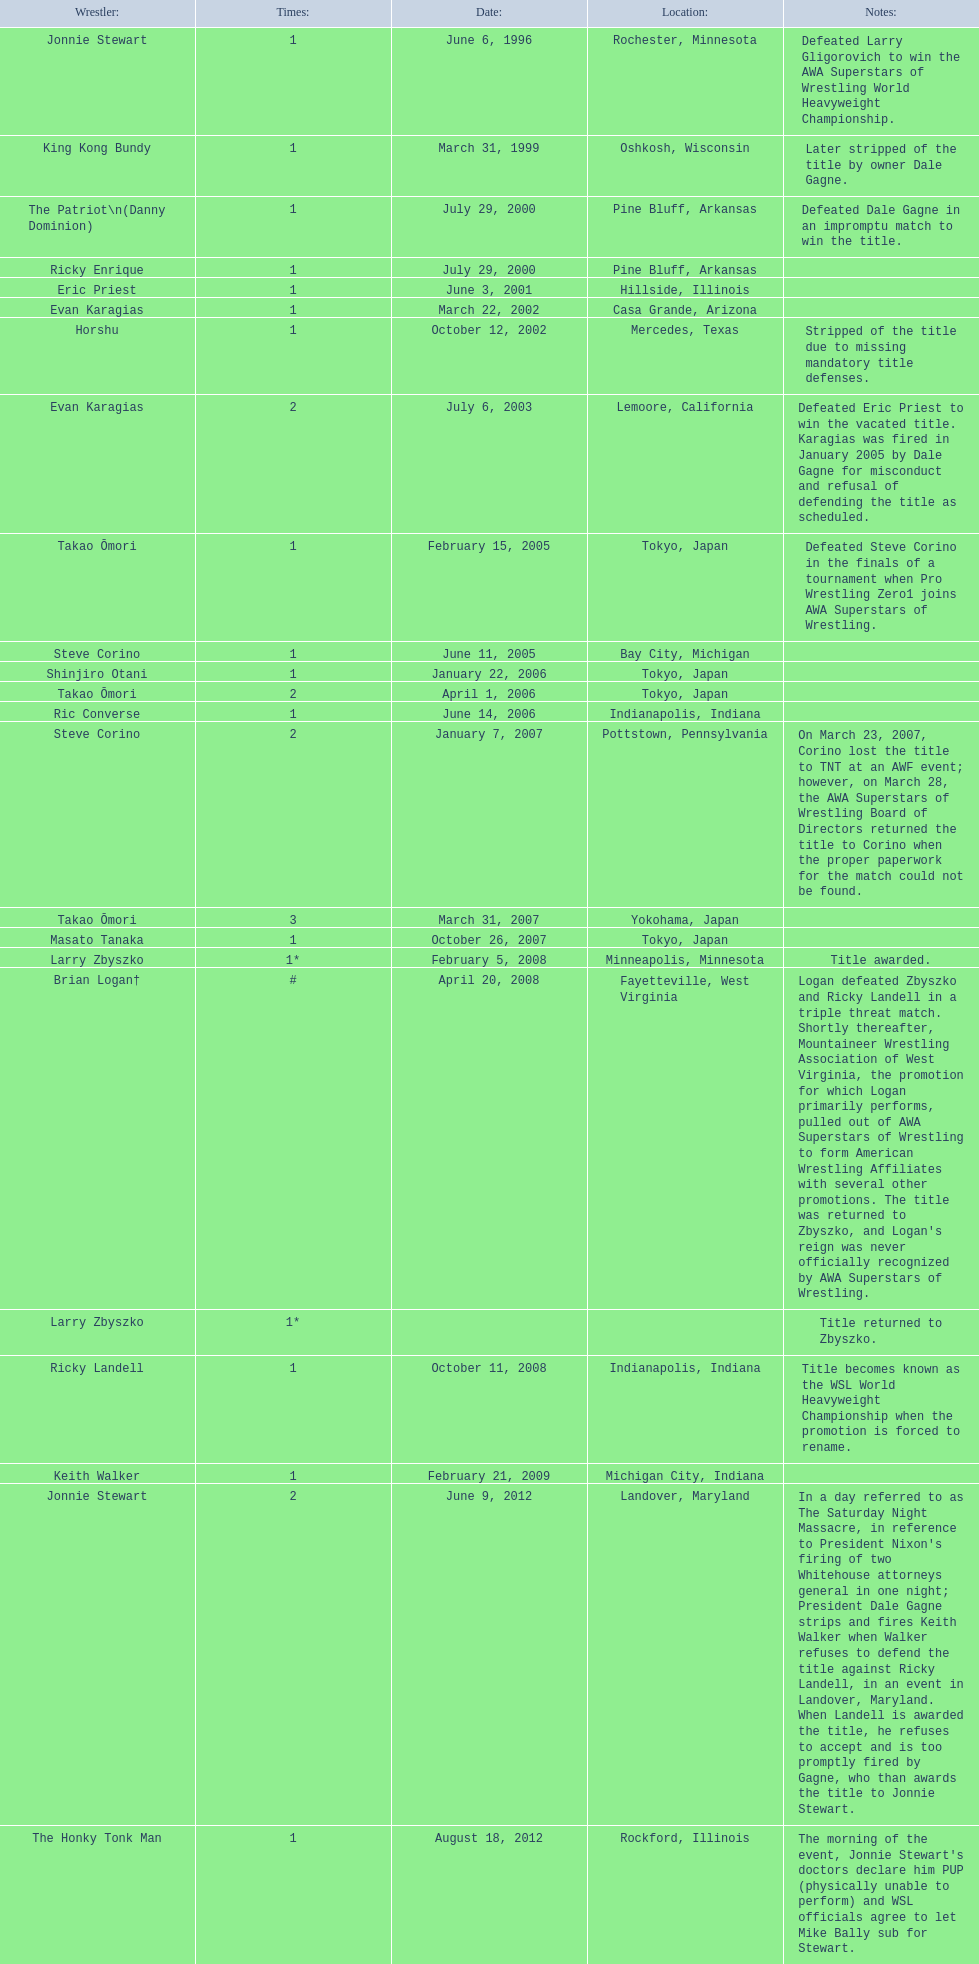Can you identify the wrestlers? Jonnie Stewart, Rochester, Minnesota, King Kong Bundy, Oshkosh, Wisconsin, The Patriot\n(Danny Dominion), Pine Bluff, Arkansas, Ricky Enrique, Pine Bluff, Arkansas, Eric Priest, Hillside, Illinois, Evan Karagias, Casa Grande, Arizona, Horshu, Mercedes, Texas, Evan Karagias, Lemoore, California, Takao Ōmori, Tokyo, Japan, Steve Corino, Bay City, Michigan, Shinjiro Otani, Tokyo, Japan, Takao Ōmori, Tokyo, Japan, Ric Converse, Indianapolis, Indiana, Steve Corino, Pottstown, Pennsylvania, Takao Ōmori, Yokohama, Japan, Masato Tanaka, Tokyo, Japan, Larry Zbyszko, Minneapolis, Minnesota, Brian Logan†, Fayetteville, West Virginia, Larry Zbyszko, , Ricky Landell, Indianapolis, Indiana, Keith Walker, Michigan City, Indiana, Jonnie Stewart, Landover, Maryland, The Honky Tonk Man, Rockford, Illinois. Which one of them is a texan? Horshu, Mercedes, Texas. Who could that individual be? Horshu. 